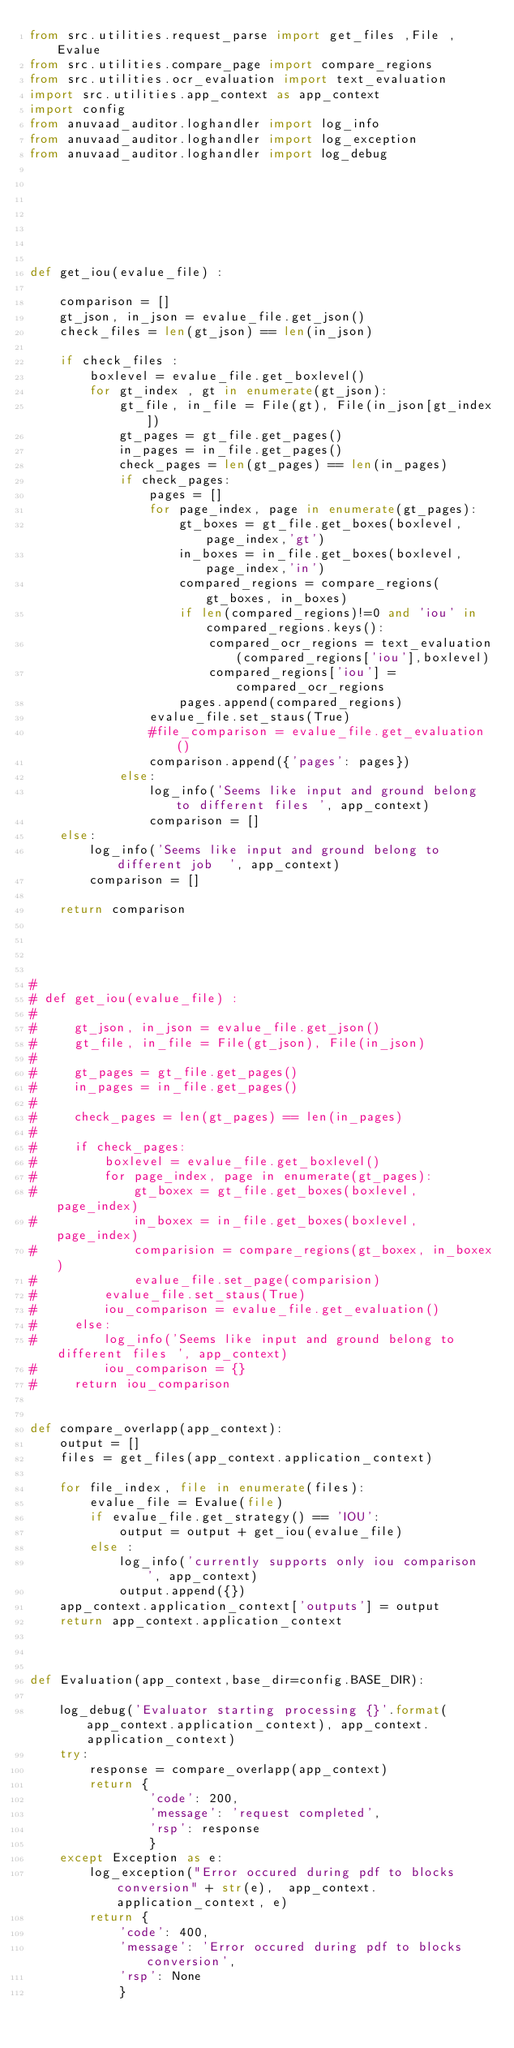<code> <loc_0><loc_0><loc_500><loc_500><_Python_>from src.utilities.request_parse import get_files ,File ,Evalue
from src.utilities.compare_page import compare_regions
from src.utilities.ocr_evaluation import text_evaluation
import src.utilities.app_context as app_context
import config
from anuvaad_auditor.loghandler import log_info
from anuvaad_auditor.loghandler import log_exception
from anuvaad_auditor.loghandler import log_debug







def get_iou(evalue_file) :

    comparison = []
    gt_json, in_json = evalue_file.get_json()
    check_files = len(gt_json) == len(in_json)

    if check_files :
        boxlevel = evalue_file.get_boxlevel()
        for gt_index , gt in enumerate(gt_json):
            gt_file, in_file = File(gt), File(in_json[gt_index])
            gt_pages = gt_file.get_pages()
            in_pages = in_file.get_pages()
            check_pages = len(gt_pages) == len(in_pages)
            if check_pages:
                pages = []
                for page_index, page in enumerate(gt_pages):
                    gt_boxes = gt_file.get_boxes(boxlevel, page_index,'gt')
                    in_boxes = in_file.get_boxes(boxlevel, page_index,'in')
                    compared_regions = compare_regions(gt_boxes, in_boxes)
                    if len(compared_regions)!=0 and 'iou' in compared_regions.keys():
                        compared_ocr_regions = text_evaluation(compared_regions['iou'],boxlevel)
                        compared_regions['iou'] = compared_ocr_regions
                    pages.append(compared_regions)
                evalue_file.set_staus(True)
                #file_comparison = evalue_file.get_evaluation()
                comparison.append({'pages': pages})
            else:
                log_info('Seems like input and ground belong to different files ', app_context)
                comparison = []
    else:
        log_info('Seems like input and ground belong to different job  ', app_context)
        comparison = []

    return comparison




#
# def get_iou(evalue_file) :
#
#     gt_json, in_json = evalue_file.get_json()
#     gt_file, in_file = File(gt_json), File(in_json)
#
#     gt_pages = gt_file.get_pages()
#     in_pages = in_file.get_pages()
#
#     check_pages = len(gt_pages) == len(in_pages)
#
#     if check_pages:
#         boxlevel = evalue_file.get_boxlevel()
#         for page_index, page in enumerate(gt_pages):
#             gt_boxex = gt_file.get_boxes(boxlevel, page_index)
#             in_boxex = in_file.get_boxes(boxlevel, page_index)
#             comparision = compare_regions(gt_boxex, in_boxex)
#             evalue_file.set_page(comparision)
#         evalue_file.set_staus(True)
#         iou_comparison = evalue_file.get_evaluation()
#     else:
#         log_info('Seems like input and ground belong to different files ', app_context)
#         iou_comparison = {}
#     return iou_comparison


def compare_overlapp(app_context):
    output = []
    files = get_files(app_context.application_context)

    for file_index, file in enumerate(files):
        evalue_file = Evalue(file)
        if evalue_file.get_strategy() == 'IOU':
            output = output + get_iou(evalue_file)
        else :
            log_info('currently supports only iou comparison  ', app_context)
            output.append({})
    app_context.application_context['outputs'] = output
    return app_context.application_context



def Evaluation(app_context,base_dir=config.BASE_DIR):

    log_debug('Evaluator starting processing {}'.format(app_context.application_context), app_context.application_context)
    try:
        response = compare_overlapp(app_context)
        return {
                'code': 200,
                'message': 'request completed',
                'rsp': response
                }
    except Exception as e:
        log_exception("Error occured during pdf to blocks conversion" + str(e),  app_context.application_context, e)
        return {
            'code': 400,
            'message': 'Error occured during pdf to blocks conversion',
            'rsp': None
            }
</code> 